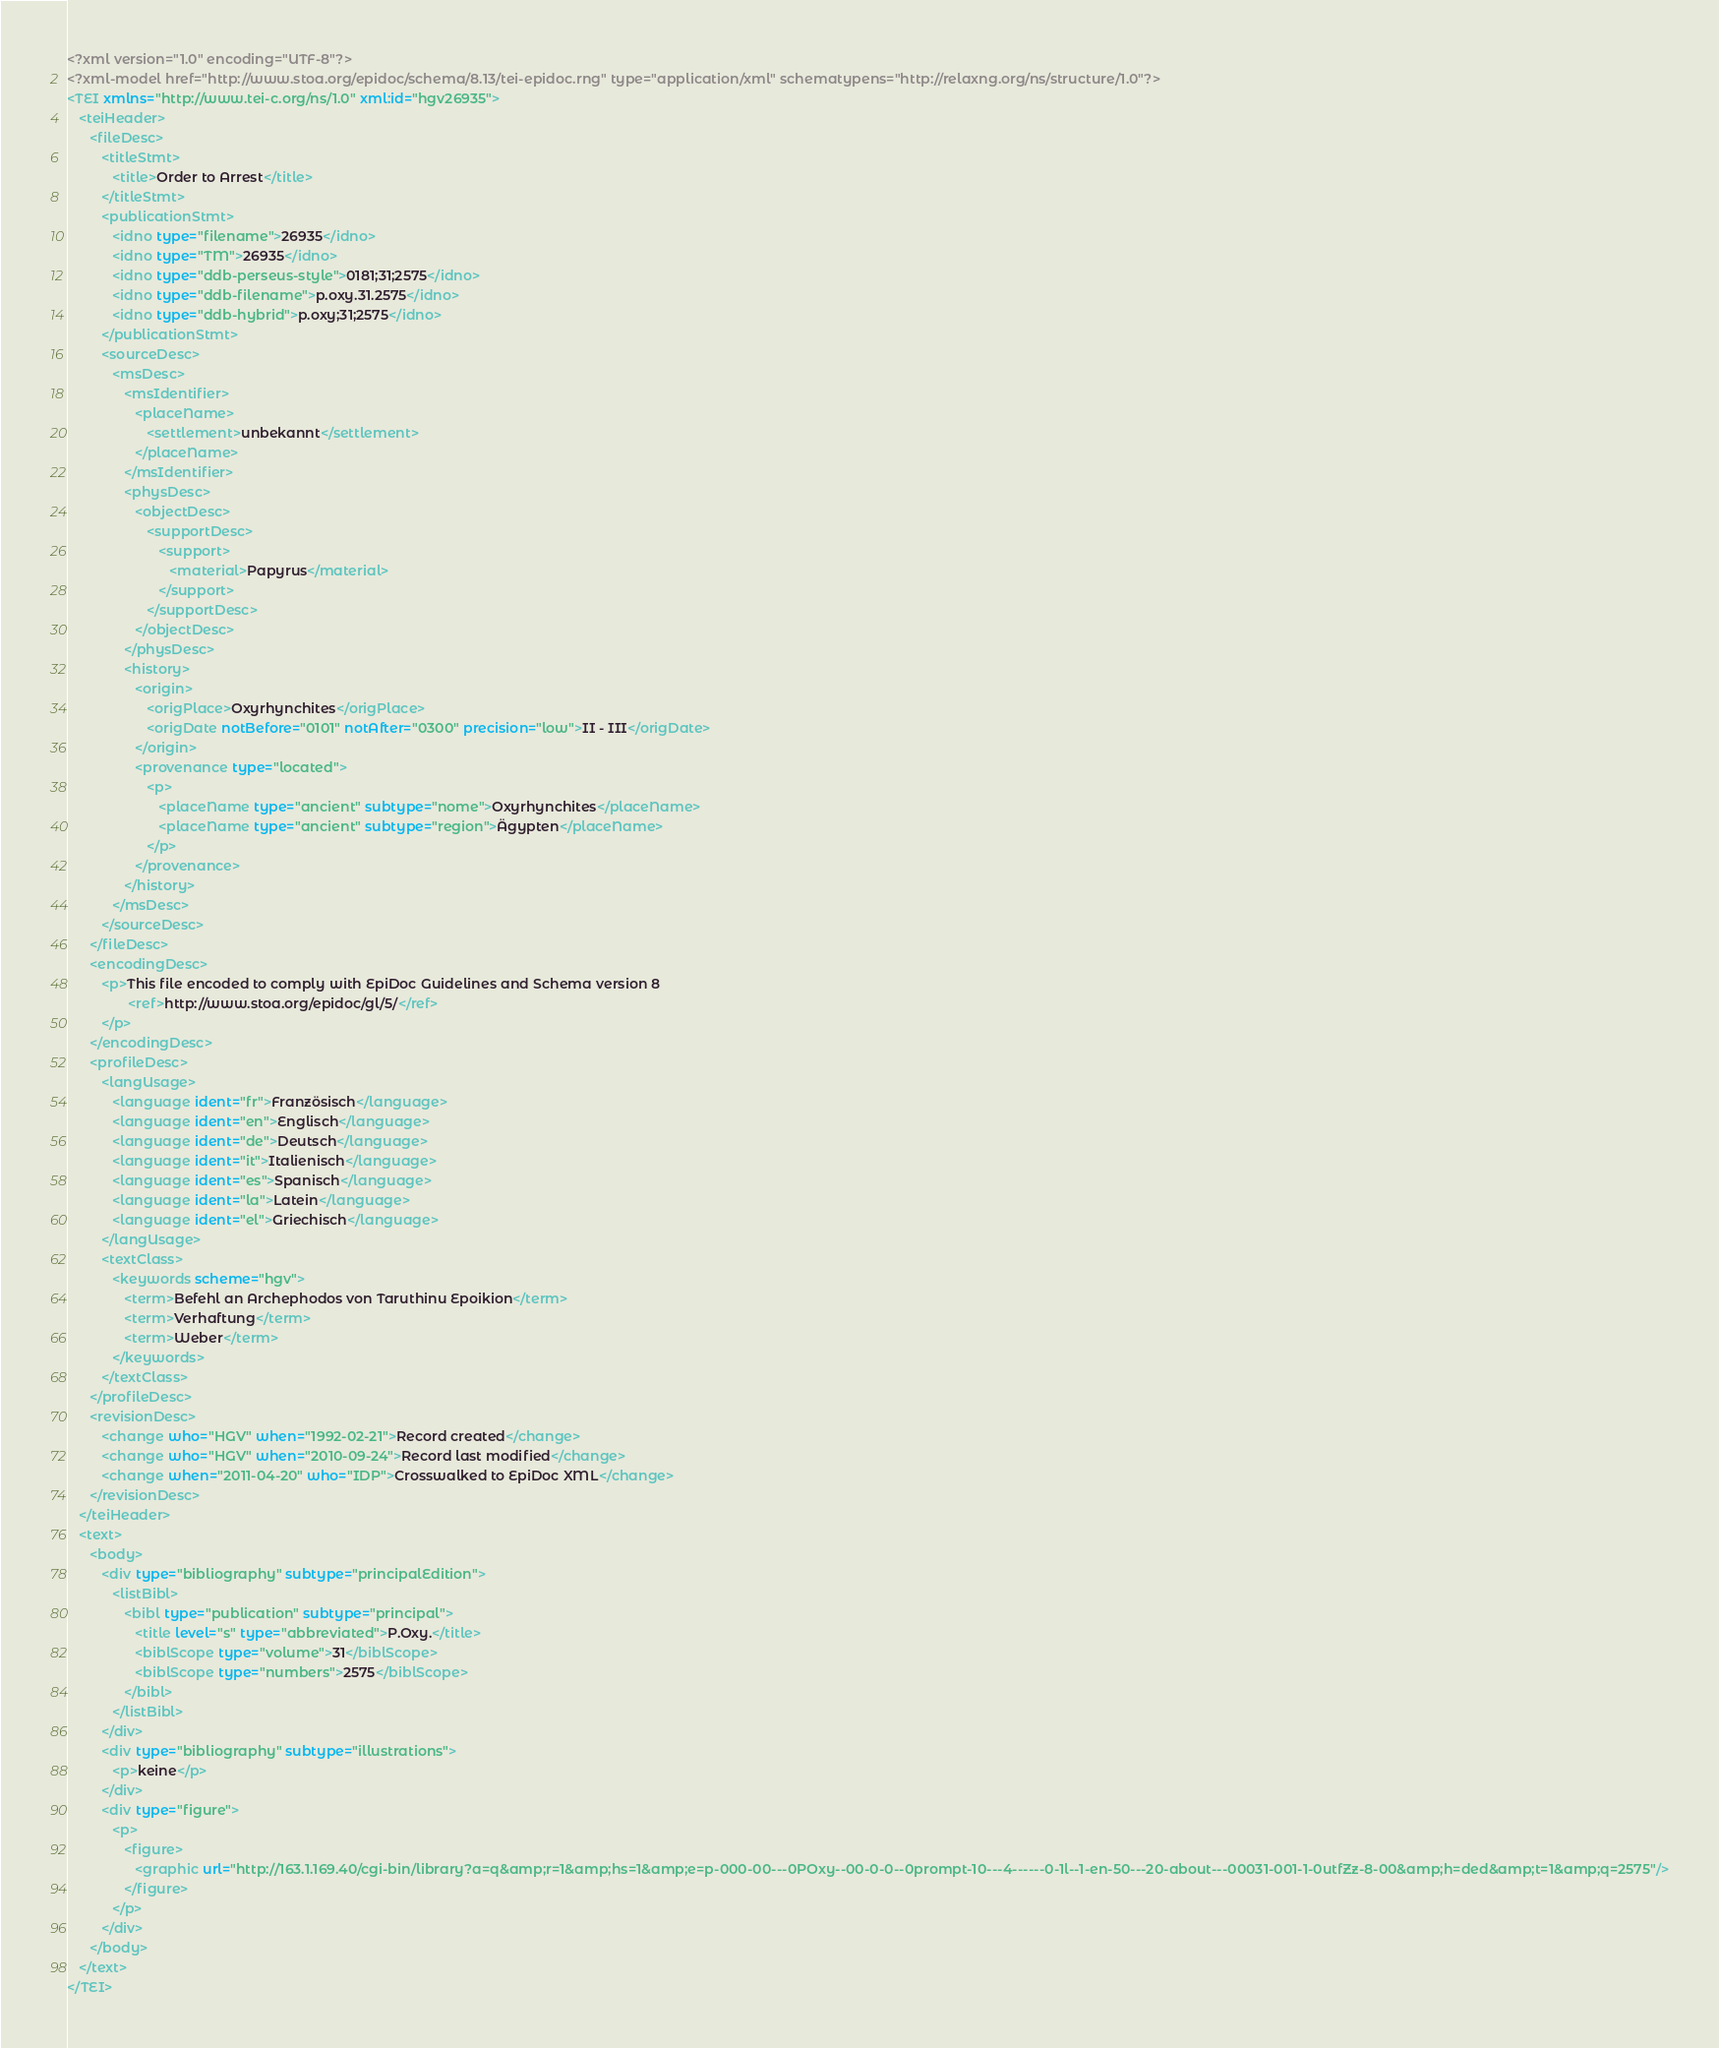Convert code to text. <code><loc_0><loc_0><loc_500><loc_500><_XML_><?xml version="1.0" encoding="UTF-8"?>
<?xml-model href="http://www.stoa.org/epidoc/schema/8.13/tei-epidoc.rng" type="application/xml" schematypens="http://relaxng.org/ns/structure/1.0"?>
<TEI xmlns="http://www.tei-c.org/ns/1.0" xml:id="hgv26935">
   <teiHeader>
      <fileDesc>
         <titleStmt>
            <title>Order to Arrest</title>
         </titleStmt>
         <publicationStmt>
            <idno type="filename">26935</idno>
            <idno type="TM">26935</idno>
            <idno type="ddb-perseus-style">0181;31;2575</idno>
            <idno type="ddb-filename">p.oxy.31.2575</idno>
            <idno type="ddb-hybrid">p.oxy;31;2575</idno>
         </publicationStmt>
         <sourceDesc>
            <msDesc>
               <msIdentifier>
                  <placeName>
                     <settlement>unbekannt</settlement>
                  </placeName>
               </msIdentifier>
               <physDesc>
                  <objectDesc>
                     <supportDesc>
                        <support>
                           <material>Papyrus</material>
                        </support>
                     </supportDesc>
                  </objectDesc>
               </physDesc>
               <history>
                  <origin>
                     <origPlace>Oxyrhynchites</origPlace>
                     <origDate notBefore="0101" notAfter="0300" precision="low">II - III</origDate>
                  </origin>
                  <provenance type="located">
                     <p>
                        <placeName type="ancient" subtype="nome">Oxyrhynchites</placeName>
                        <placeName type="ancient" subtype="region">Ägypten</placeName>
                     </p>
                  </provenance>
               </history>
            </msDesc>
         </sourceDesc>
      </fileDesc>
      <encodingDesc>
         <p>This file encoded to comply with EpiDoc Guidelines and Schema version 8
                <ref>http://www.stoa.org/epidoc/gl/5/</ref>
         </p>
      </encodingDesc>
      <profileDesc>
         <langUsage>
            <language ident="fr">Französisch</language>
            <language ident="en">Englisch</language>
            <language ident="de">Deutsch</language>
            <language ident="it">Italienisch</language>
            <language ident="es">Spanisch</language>
            <language ident="la">Latein</language>
            <language ident="el">Griechisch</language>
         </langUsage>
         <textClass>
            <keywords scheme="hgv">
               <term>Befehl an Archephodos von Taruthinu Epoikion</term>
               <term>Verhaftung</term>
               <term>Weber</term>
            </keywords>
         </textClass>
      </profileDesc>
      <revisionDesc>
         <change who="HGV" when="1992-02-21">Record created</change>
         <change who="HGV" when="2010-09-24">Record last modified</change>
         <change when="2011-04-20" who="IDP">Crosswalked to EpiDoc XML</change>
      </revisionDesc>
   </teiHeader>
   <text>
      <body>
         <div type="bibliography" subtype="principalEdition">
            <listBibl>
               <bibl type="publication" subtype="principal">
                  <title level="s" type="abbreviated">P.Oxy.</title>
                  <biblScope type="volume">31</biblScope>
                  <biblScope type="numbers">2575</biblScope>
               </bibl>
            </listBibl>
         </div>
         <div type="bibliography" subtype="illustrations">
            <p>keine</p>
         </div>
         <div type="figure">
            <p>
               <figure>
                  <graphic url="http://163.1.169.40/cgi-bin/library?a=q&amp;r=1&amp;hs=1&amp;e=p-000-00---0POxy--00-0-0--0prompt-10---4------0-1l--1-en-50---20-about---00031-001-1-0utfZz-8-00&amp;h=ded&amp;t=1&amp;q=2575"/>
               </figure>
            </p>
         </div>
      </body>
   </text>
</TEI>
</code> 